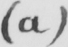What text is written in this handwritten line? ( a ) 